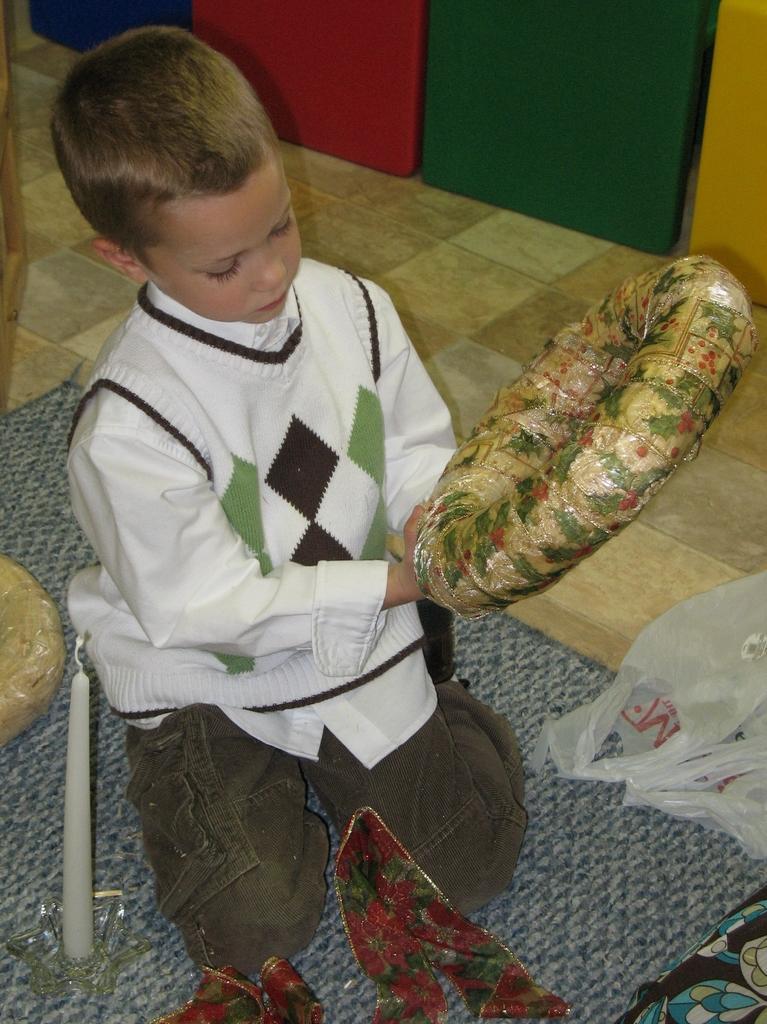Describe this image in one or two sentences. In the foreground I can see a boy is holding an object in hand. In the background I can see boxes. This image is taken may be in a hall. 